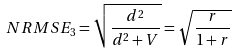<formula> <loc_0><loc_0><loc_500><loc_500>N R M S E _ { 3 } = \sqrt { \frac { d ^ { 2 } } { d ^ { 2 } + V } } = \sqrt { \frac { r } { 1 + r } }</formula> 